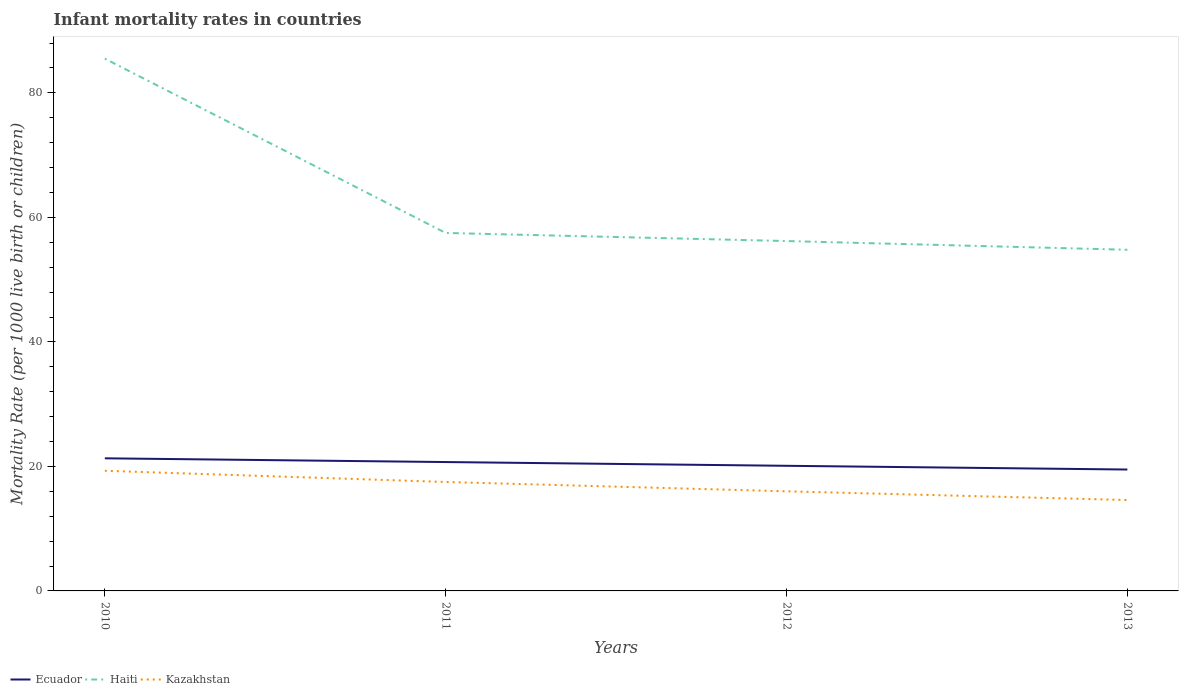Is the number of lines equal to the number of legend labels?
Ensure brevity in your answer.  Yes. Across all years, what is the maximum infant mortality rate in Haiti?
Ensure brevity in your answer.  54.8. In which year was the infant mortality rate in Haiti maximum?
Offer a very short reply. 2013. What is the total infant mortality rate in Ecuador in the graph?
Give a very brief answer. 1.2. What is the difference between the highest and the second highest infant mortality rate in Haiti?
Make the answer very short. 30.7. What is the difference between the highest and the lowest infant mortality rate in Haiti?
Offer a very short reply. 1. Is the infant mortality rate in Ecuador strictly greater than the infant mortality rate in Haiti over the years?
Provide a succinct answer. Yes. Does the graph contain any zero values?
Your answer should be compact. No. What is the title of the graph?
Provide a succinct answer. Infant mortality rates in countries. Does "Malaysia" appear as one of the legend labels in the graph?
Give a very brief answer. No. What is the label or title of the X-axis?
Your answer should be compact. Years. What is the label or title of the Y-axis?
Your answer should be very brief. Mortality Rate (per 1000 live birth or children). What is the Mortality Rate (per 1000 live birth or children) of Ecuador in 2010?
Your answer should be very brief. 21.3. What is the Mortality Rate (per 1000 live birth or children) of Haiti in 2010?
Give a very brief answer. 85.5. What is the Mortality Rate (per 1000 live birth or children) of Kazakhstan in 2010?
Keep it short and to the point. 19.3. What is the Mortality Rate (per 1000 live birth or children) of Ecuador in 2011?
Ensure brevity in your answer.  20.7. What is the Mortality Rate (per 1000 live birth or children) of Haiti in 2011?
Offer a terse response. 57.5. What is the Mortality Rate (per 1000 live birth or children) in Ecuador in 2012?
Offer a terse response. 20.1. What is the Mortality Rate (per 1000 live birth or children) in Haiti in 2012?
Your answer should be very brief. 56.2. What is the Mortality Rate (per 1000 live birth or children) in Kazakhstan in 2012?
Your answer should be compact. 16. What is the Mortality Rate (per 1000 live birth or children) in Haiti in 2013?
Your answer should be very brief. 54.8. Across all years, what is the maximum Mortality Rate (per 1000 live birth or children) in Ecuador?
Provide a short and direct response. 21.3. Across all years, what is the maximum Mortality Rate (per 1000 live birth or children) in Haiti?
Offer a terse response. 85.5. Across all years, what is the maximum Mortality Rate (per 1000 live birth or children) in Kazakhstan?
Provide a short and direct response. 19.3. Across all years, what is the minimum Mortality Rate (per 1000 live birth or children) in Ecuador?
Provide a short and direct response. 19.5. Across all years, what is the minimum Mortality Rate (per 1000 live birth or children) in Haiti?
Offer a very short reply. 54.8. What is the total Mortality Rate (per 1000 live birth or children) of Ecuador in the graph?
Offer a very short reply. 81.6. What is the total Mortality Rate (per 1000 live birth or children) in Haiti in the graph?
Offer a terse response. 254. What is the total Mortality Rate (per 1000 live birth or children) of Kazakhstan in the graph?
Provide a succinct answer. 67.4. What is the difference between the Mortality Rate (per 1000 live birth or children) in Ecuador in 2010 and that in 2011?
Your answer should be very brief. 0.6. What is the difference between the Mortality Rate (per 1000 live birth or children) in Haiti in 2010 and that in 2012?
Your response must be concise. 29.3. What is the difference between the Mortality Rate (per 1000 live birth or children) of Haiti in 2010 and that in 2013?
Your answer should be compact. 30.7. What is the difference between the Mortality Rate (per 1000 live birth or children) of Ecuador in 2011 and that in 2012?
Offer a very short reply. 0.6. What is the difference between the Mortality Rate (per 1000 live birth or children) in Kazakhstan in 2011 and that in 2012?
Your answer should be very brief. 1.5. What is the difference between the Mortality Rate (per 1000 live birth or children) in Haiti in 2011 and that in 2013?
Provide a short and direct response. 2.7. What is the difference between the Mortality Rate (per 1000 live birth or children) of Ecuador in 2012 and that in 2013?
Your response must be concise. 0.6. What is the difference between the Mortality Rate (per 1000 live birth or children) of Haiti in 2012 and that in 2013?
Your answer should be very brief. 1.4. What is the difference between the Mortality Rate (per 1000 live birth or children) in Kazakhstan in 2012 and that in 2013?
Offer a very short reply. 1.4. What is the difference between the Mortality Rate (per 1000 live birth or children) in Ecuador in 2010 and the Mortality Rate (per 1000 live birth or children) in Haiti in 2011?
Your answer should be very brief. -36.2. What is the difference between the Mortality Rate (per 1000 live birth or children) of Ecuador in 2010 and the Mortality Rate (per 1000 live birth or children) of Kazakhstan in 2011?
Provide a succinct answer. 3.8. What is the difference between the Mortality Rate (per 1000 live birth or children) of Ecuador in 2010 and the Mortality Rate (per 1000 live birth or children) of Haiti in 2012?
Keep it short and to the point. -34.9. What is the difference between the Mortality Rate (per 1000 live birth or children) of Ecuador in 2010 and the Mortality Rate (per 1000 live birth or children) of Kazakhstan in 2012?
Provide a short and direct response. 5.3. What is the difference between the Mortality Rate (per 1000 live birth or children) in Haiti in 2010 and the Mortality Rate (per 1000 live birth or children) in Kazakhstan in 2012?
Offer a very short reply. 69.5. What is the difference between the Mortality Rate (per 1000 live birth or children) in Ecuador in 2010 and the Mortality Rate (per 1000 live birth or children) in Haiti in 2013?
Offer a very short reply. -33.5. What is the difference between the Mortality Rate (per 1000 live birth or children) in Haiti in 2010 and the Mortality Rate (per 1000 live birth or children) in Kazakhstan in 2013?
Your answer should be compact. 70.9. What is the difference between the Mortality Rate (per 1000 live birth or children) of Ecuador in 2011 and the Mortality Rate (per 1000 live birth or children) of Haiti in 2012?
Your response must be concise. -35.5. What is the difference between the Mortality Rate (per 1000 live birth or children) of Haiti in 2011 and the Mortality Rate (per 1000 live birth or children) of Kazakhstan in 2012?
Your answer should be compact. 41.5. What is the difference between the Mortality Rate (per 1000 live birth or children) of Ecuador in 2011 and the Mortality Rate (per 1000 live birth or children) of Haiti in 2013?
Offer a terse response. -34.1. What is the difference between the Mortality Rate (per 1000 live birth or children) of Ecuador in 2011 and the Mortality Rate (per 1000 live birth or children) of Kazakhstan in 2013?
Keep it short and to the point. 6.1. What is the difference between the Mortality Rate (per 1000 live birth or children) in Haiti in 2011 and the Mortality Rate (per 1000 live birth or children) in Kazakhstan in 2013?
Give a very brief answer. 42.9. What is the difference between the Mortality Rate (per 1000 live birth or children) in Ecuador in 2012 and the Mortality Rate (per 1000 live birth or children) in Haiti in 2013?
Offer a terse response. -34.7. What is the difference between the Mortality Rate (per 1000 live birth or children) of Ecuador in 2012 and the Mortality Rate (per 1000 live birth or children) of Kazakhstan in 2013?
Offer a very short reply. 5.5. What is the difference between the Mortality Rate (per 1000 live birth or children) in Haiti in 2012 and the Mortality Rate (per 1000 live birth or children) in Kazakhstan in 2013?
Make the answer very short. 41.6. What is the average Mortality Rate (per 1000 live birth or children) in Ecuador per year?
Your response must be concise. 20.4. What is the average Mortality Rate (per 1000 live birth or children) of Haiti per year?
Your answer should be very brief. 63.5. What is the average Mortality Rate (per 1000 live birth or children) of Kazakhstan per year?
Give a very brief answer. 16.85. In the year 2010, what is the difference between the Mortality Rate (per 1000 live birth or children) of Ecuador and Mortality Rate (per 1000 live birth or children) of Haiti?
Offer a very short reply. -64.2. In the year 2010, what is the difference between the Mortality Rate (per 1000 live birth or children) in Haiti and Mortality Rate (per 1000 live birth or children) in Kazakhstan?
Offer a very short reply. 66.2. In the year 2011, what is the difference between the Mortality Rate (per 1000 live birth or children) of Ecuador and Mortality Rate (per 1000 live birth or children) of Haiti?
Ensure brevity in your answer.  -36.8. In the year 2011, what is the difference between the Mortality Rate (per 1000 live birth or children) in Ecuador and Mortality Rate (per 1000 live birth or children) in Kazakhstan?
Your answer should be compact. 3.2. In the year 2011, what is the difference between the Mortality Rate (per 1000 live birth or children) of Haiti and Mortality Rate (per 1000 live birth or children) of Kazakhstan?
Your answer should be compact. 40. In the year 2012, what is the difference between the Mortality Rate (per 1000 live birth or children) of Ecuador and Mortality Rate (per 1000 live birth or children) of Haiti?
Your answer should be compact. -36.1. In the year 2012, what is the difference between the Mortality Rate (per 1000 live birth or children) in Haiti and Mortality Rate (per 1000 live birth or children) in Kazakhstan?
Keep it short and to the point. 40.2. In the year 2013, what is the difference between the Mortality Rate (per 1000 live birth or children) in Ecuador and Mortality Rate (per 1000 live birth or children) in Haiti?
Your response must be concise. -35.3. In the year 2013, what is the difference between the Mortality Rate (per 1000 live birth or children) in Haiti and Mortality Rate (per 1000 live birth or children) in Kazakhstan?
Ensure brevity in your answer.  40.2. What is the ratio of the Mortality Rate (per 1000 live birth or children) of Ecuador in 2010 to that in 2011?
Make the answer very short. 1.03. What is the ratio of the Mortality Rate (per 1000 live birth or children) in Haiti in 2010 to that in 2011?
Provide a succinct answer. 1.49. What is the ratio of the Mortality Rate (per 1000 live birth or children) in Kazakhstan in 2010 to that in 2011?
Keep it short and to the point. 1.1. What is the ratio of the Mortality Rate (per 1000 live birth or children) in Ecuador in 2010 to that in 2012?
Your response must be concise. 1.06. What is the ratio of the Mortality Rate (per 1000 live birth or children) in Haiti in 2010 to that in 2012?
Your response must be concise. 1.52. What is the ratio of the Mortality Rate (per 1000 live birth or children) in Kazakhstan in 2010 to that in 2012?
Provide a short and direct response. 1.21. What is the ratio of the Mortality Rate (per 1000 live birth or children) of Ecuador in 2010 to that in 2013?
Keep it short and to the point. 1.09. What is the ratio of the Mortality Rate (per 1000 live birth or children) in Haiti in 2010 to that in 2013?
Make the answer very short. 1.56. What is the ratio of the Mortality Rate (per 1000 live birth or children) in Kazakhstan in 2010 to that in 2013?
Your answer should be compact. 1.32. What is the ratio of the Mortality Rate (per 1000 live birth or children) of Ecuador in 2011 to that in 2012?
Provide a short and direct response. 1.03. What is the ratio of the Mortality Rate (per 1000 live birth or children) in Haiti in 2011 to that in 2012?
Offer a terse response. 1.02. What is the ratio of the Mortality Rate (per 1000 live birth or children) in Kazakhstan in 2011 to that in 2012?
Your answer should be very brief. 1.09. What is the ratio of the Mortality Rate (per 1000 live birth or children) of Ecuador in 2011 to that in 2013?
Provide a short and direct response. 1.06. What is the ratio of the Mortality Rate (per 1000 live birth or children) in Haiti in 2011 to that in 2013?
Offer a very short reply. 1.05. What is the ratio of the Mortality Rate (per 1000 live birth or children) in Kazakhstan in 2011 to that in 2013?
Provide a short and direct response. 1.2. What is the ratio of the Mortality Rate (per 1000 live birth or children) in Ecuador in 2012 to that in 2013?
Offer a very short reply. 1.03. What is the ratio of the Mortality Rate (per 1000 live birth or children) in Haiti in 2012 to that in 2013?
Your response must be concise. 1.03. What is the ratio of the Mortality Rate (per 1000 live birth or children) of Kazakhstan in 2012 to that in 2013?
Ensure brevity in your answer.  1.1. What is the difference between the highest and the second highest Mortality Rate (per 1000 live birth or children) in Haiti?
Your answer should be compact. 28. What is the difference between the highest and the second highest Mortality Rate (per 1000 live birth or children) of Kazakhstan?
Your answer should be very brief. 1.8. What is the difference between the highest and the lowest Mortality Rate (per 1000 live birth or children) of Haiti?
Make the answer very short. 30.7. What is the difference between the highest and the lowest Mortality Rate (per 1000 live birth or children) of Kazakhstan?
Provide a succinct answer. 4.7. 